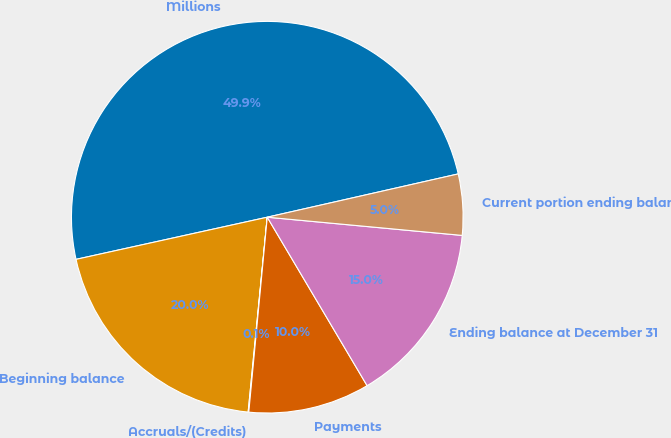Convert chart to OTSL. <chart><loc_0><loc_0><loc_500><loc_500><pie_chart><fcel>Millions<fcel>Beginning balance<fcel>Accruals/(Credits)<fcel>Payments<fcel>Ending balance at December 31<fcel>Current portion ending balance<nl><fcel>49.9%<fcel>19.99%<fcel>0.05%<fcel>10.02%<fcel>15.0%<fcel>5.03%<nl></chart> 